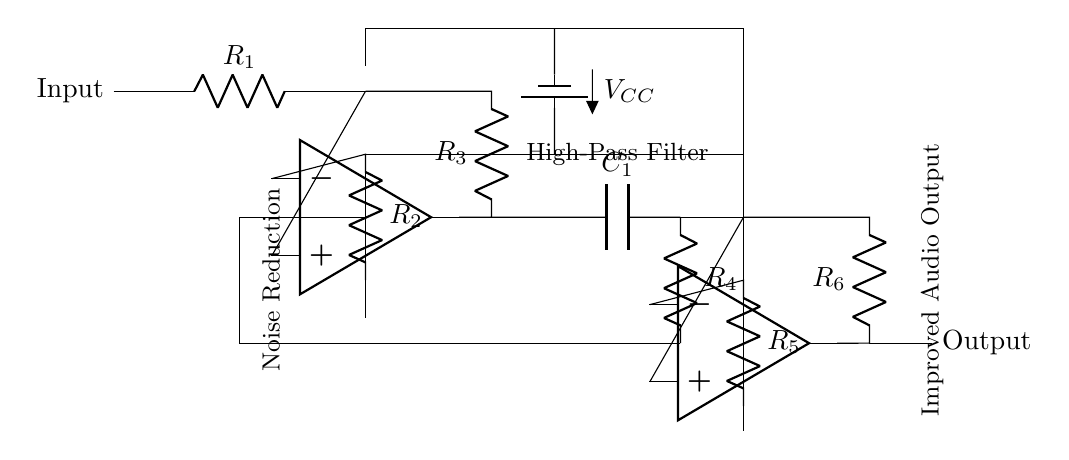What is the type of the first op-amp? The first op-amp in the circuit is primarily designed for amplification as it is placed in a feedback configuration. It takes the input signal and amplifies it to improve the overall signal quality before further processing.
Answer: Amplifier What components are used in the high-pass filter section? The high-pass filter section includes a capacitor and a resistor connected in series. The capacitor blocks low-frequency signals while allowing high frequencies to pass, thus helping to reduce noise.
Answer: Capacitor and Resistor How many resistors are in the circuit? By counting all the labeled resistors in the circuit (R1, R2, R3, R4, R5, R6), the total is determined to be 6 resistors.
Answer: 6 What is the role of the second op-amp in the circuit? The second op-amp serves a similar purpose as the first, which is to further amplify the output from the high-pass filter. This stage helps to further minimize noise and improve audio quality after initial processing.
Answer: Further amplification What kind of power supply is used in this circuit? The circuit uses a DC power supply, specifically a battery setup indicated by the voltage source symbol. This provides the required power for the op-amps and other components in the circuit.
Answer: DC power source What is the intended output of this circuit? The intended output of this circuit is an improved audio signal that has reduced noise levels, offering a clearer audio experience for the user when amplified.
Answer: Improved audio output 